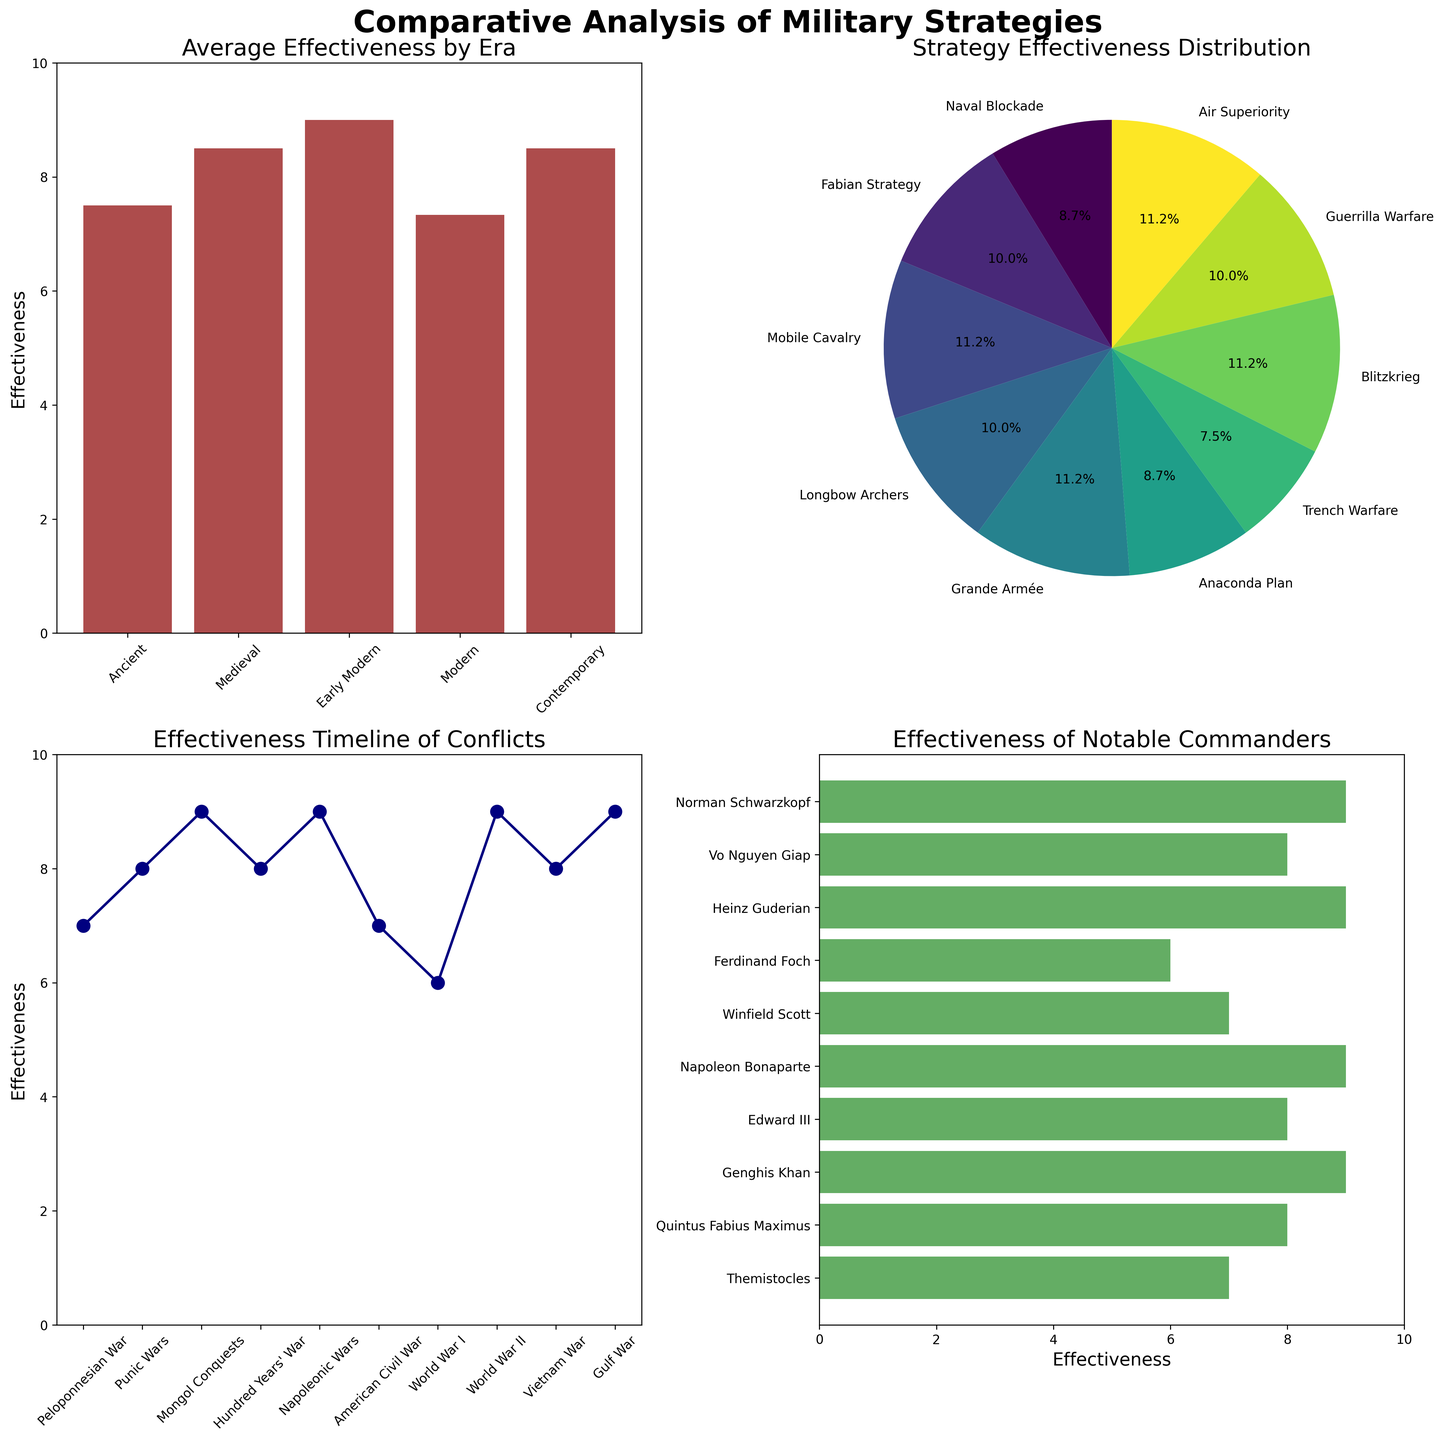what is the average effectiveness for the Early Modern era? In the 'Average Effectiveness by Era' subplot, find the bar corresponding to the Early Modern era and check the height of the bar on the y-axis, which is labeled as 'Effectiveness'.
Answer: 9 Which strategy has the highest effectiveness? In the 'Strategy Effectiveness Distribution' pie chart, find the segment that represents the highest percentage.
Answer: Blitzkrieg, Air Superiority, Grande Armée What's the effectiveness value for the Anaconda Plan strategy? In the 'Effectiveness Timeline of Conflicts' subplot, locate the 'American Civil War' conflict and look at the corresponding effectiveness value plotted.
Answer: 7 How many conflicts have an effectiveness score of 9? Check the plot 'Effectiveness Timeline of Conflicts' for points that align with the effectiveness value of 9 on the y-axis.
Answer: 4 Which commander has the lowest effectiveness rating? In the 'Effectiveness of Notable Commanders' subplot, find the bar with the lowest height, which indicates the lowest effectiveness rating.
Answer: Ferdinand Foch What is the combined effectiveness of strategies used in Ancient and Medieval eras? Locate and sum up the effectiveness values from both Ancient and Medieval eras in 'Average Effectiveness by Era' subplot.
Answer: (7 + 8) + (9 + 8) = 32 Compare the effectiveness of Guerrilla Warfare to Trench Warfare. Which one is higher? In the 'Strategy Effectiveness Distribution' pie chart, compare the segments representing Guerrilla Warfare and Trench Warfare.
Answer: Guerrilla Warfare Determine the effectiveness difference between the strategies Mobile Cavalry and Longbow Archers. In the 'Strategy Effectiveness Distribution' pie chart, find the segments for Mobile Cavalry and Longbow Archers, and subtract the effectiveness values to find the difference.
Answer: 1 